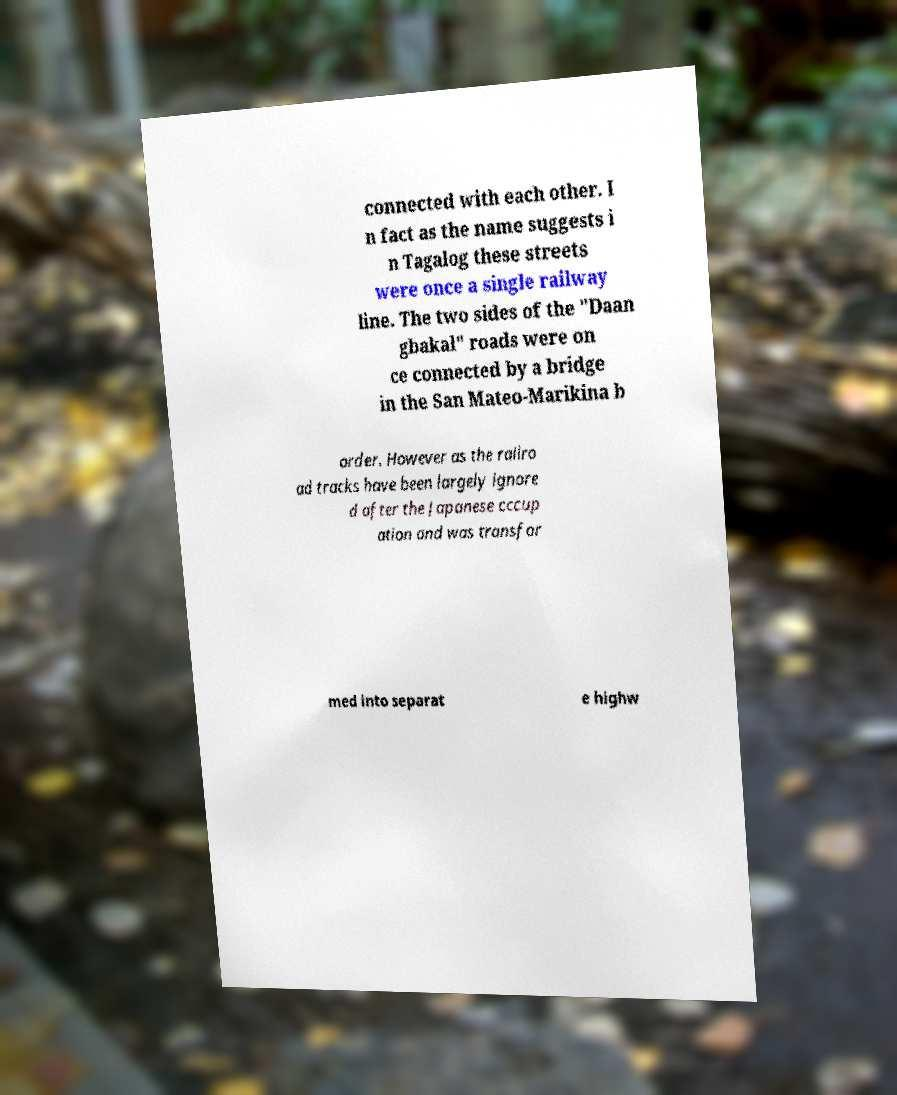Can you read and provide the text displayed in the image?This photo seems to have some interesting text. Can you extract and type it out for me? connected with each other. I n fact as the name suggests i n Tagalog these streets were once a single railway line. The two sides of the "Daan gbakal" roads were on ce connected by a bridge in the San Mateo-Marikina b order. However as the railro ad tracks have been largely ignore d after the Japanese cccup ation and was transfor med into separat e highw 